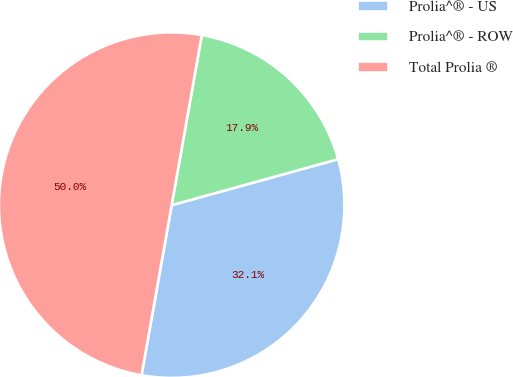Convert chart. <chart><loc_0><loc_0><loc_500><loc_500><pie_chart><fcel>Prolia^® - US<fcel>Prolia^® - ROW<fcel>Total Prolia ®<nl><fcel>32.08%<fcel>17.92%<fcel>50.0%<nl></chart> 